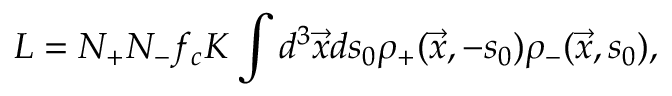<formula> <loc_0><loc_0><loc_500><loc_500>L = N _ { + } N _ { - } f _ { c } K \int d ^ { 3 } \ V e c { x } d s _ { 0 } \rho _ { + } ( \ V e c { x } , - s _ { 0 } ) \rho _ { - } ( \ V e c { x } , s _ { 0 } ) ,</formula> 